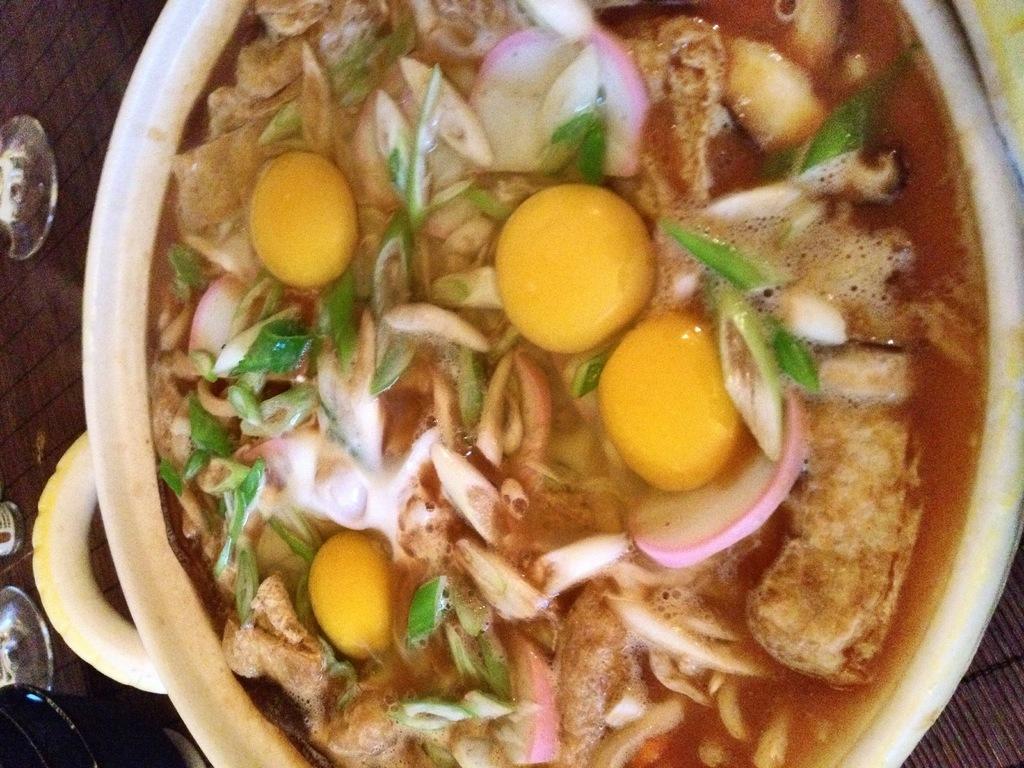Describe this image in one or two sentences. In this image I can see the bowl with food. I can see the food is colorful and the bowl is in cream and yellow color. To the side I can see few more objects and these are on the brown color surface. 